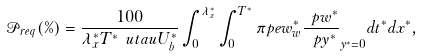Convert formula to latex. <formula><loc_0><loc_0><loc_500><loc_500>\mathcal { P } _ { r e q } ( \% ) = \frac { 1 0 0 } { \lambda _ { x } ^ { * } T ^ { * } \ u t a u U _ { b } ^ { * } } \int _ { 0 } ^ { \lambda _ { x } ^ { * } } \int _ { 0 } ^ { T ^ { * } } \pi p e { w _ { w } ^ { * } \frac { \ p w ^ { * } } { \ p y ^ { * } } } _ { y ^ { * } = 0 } d t ^ { * } d x ^ { * } ,</formula> 